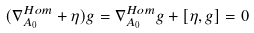<formula> <loc_0><loc_0><loc_500><loc_500>( \nabla ^ { H o m } _ { A _ { 0 } } + \eta ) g = \nabla ^ { H o m } _ { A _ { 0 } } g + [ \eta , g ] = 0</formula> 